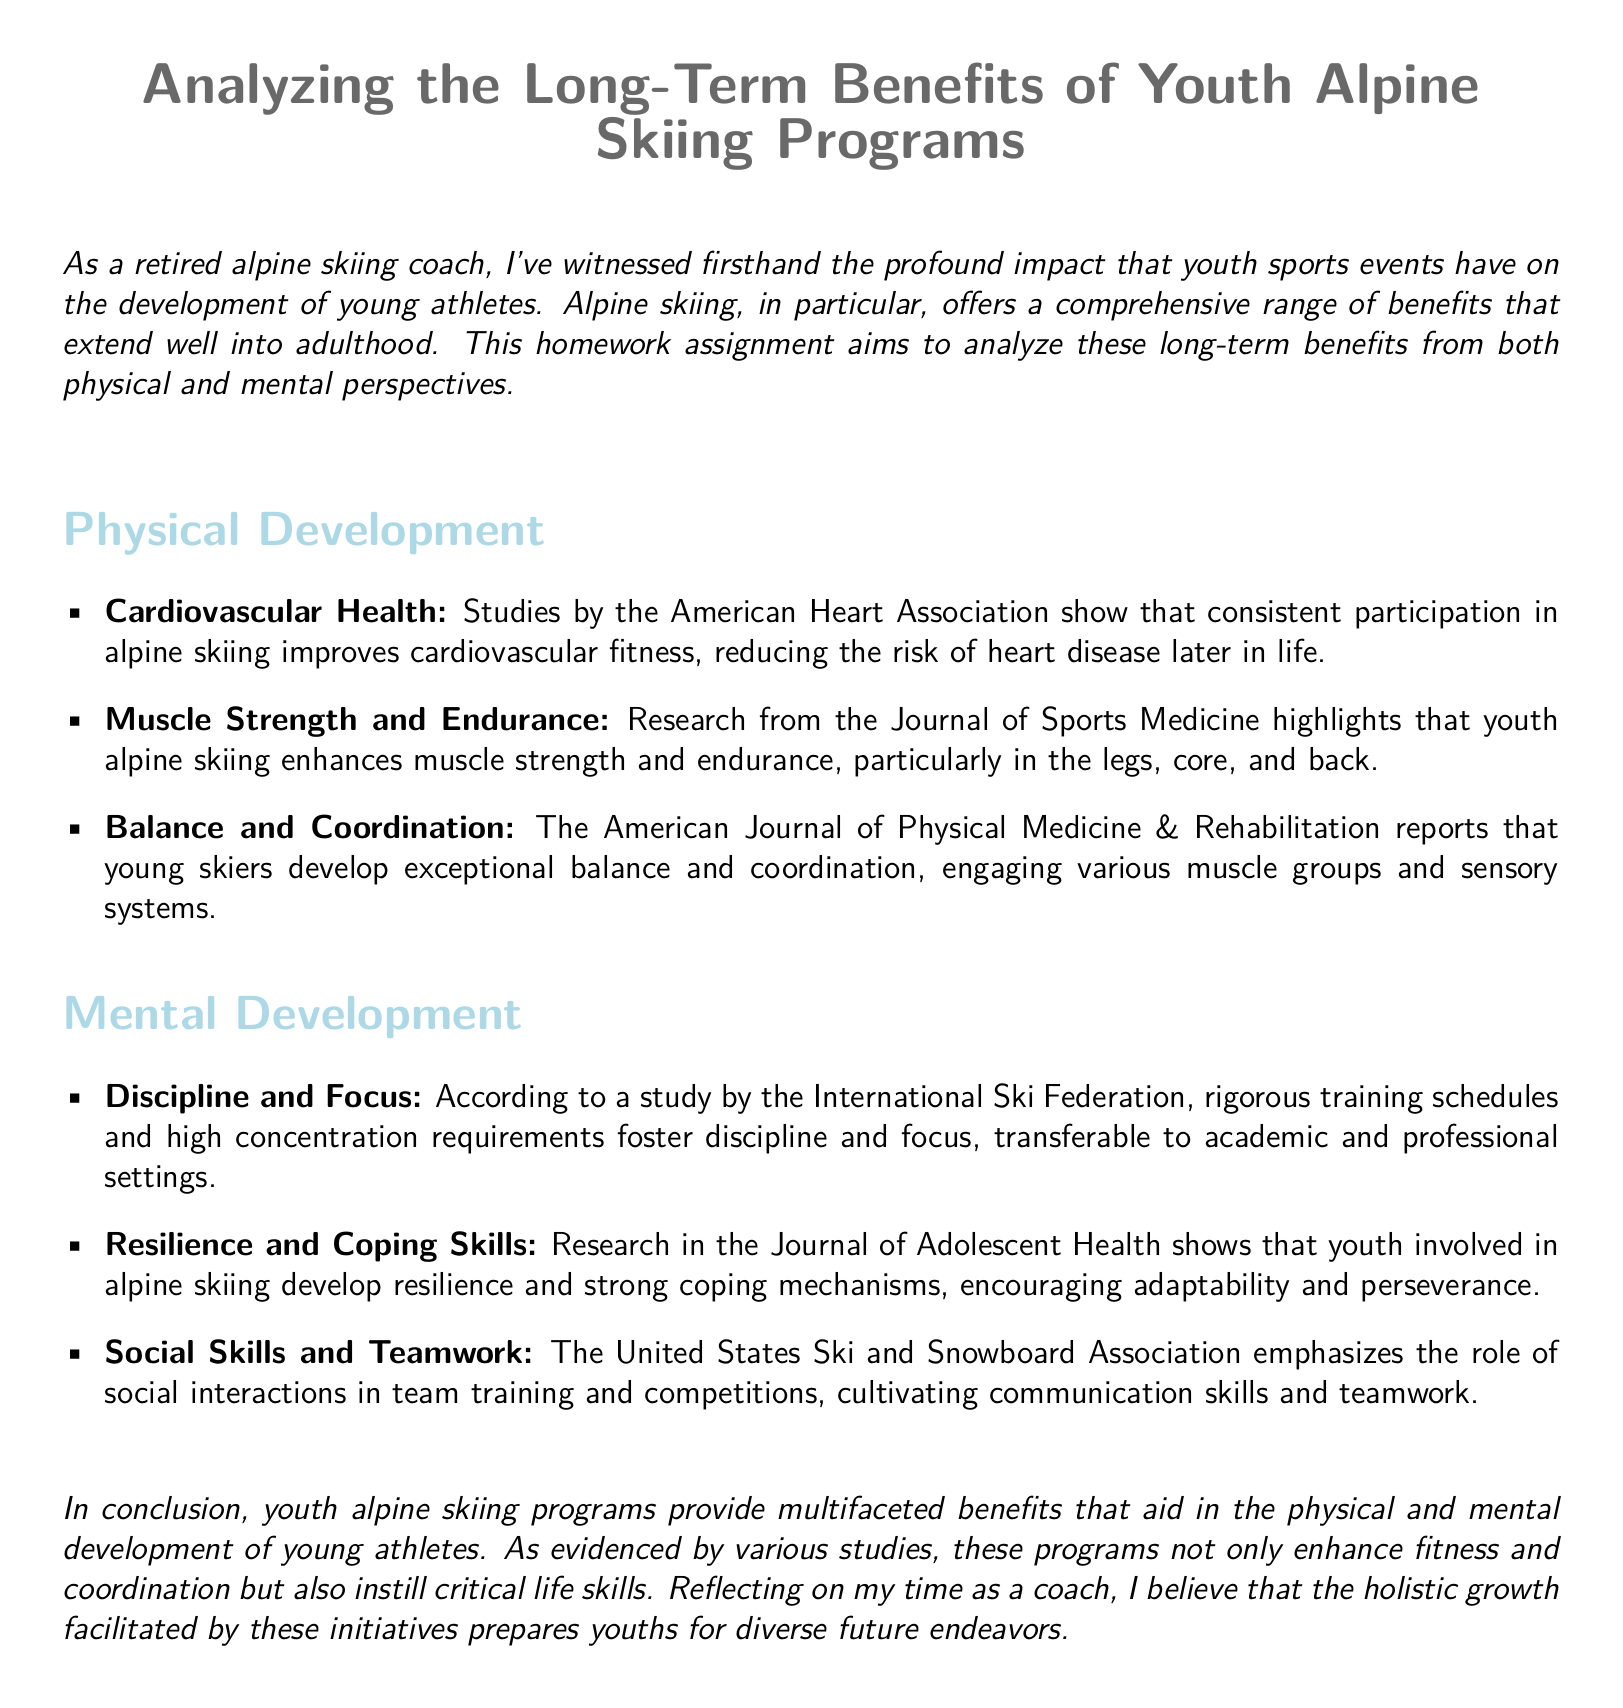What is the primary focus of the homework assignment? The assignment focuses on the long-term benefits of youth alpine skiing programs from both physical and mental perspectives.
Answer: Long-term benefits of youth alpine skiing programs What benefits are highlighted under physical development? The document lists cardiovascular health, muscle strength and endurance, balance, and coordination as physical development benefits.
Answer: Cardiovascular health, muscle strength and endurance, balance, coordination According to the document, which organization conducted research on resilience and coping skills? The research on resilience and coping skills was mentioned in the Journal of Adolescent Health.
Answer: Journal of Adolescent Health What does the American Journal of Physical Medicine & Rehabilitation report? It reports that young skiers develop exceptional balance and coordination.
Answer: Young skiers develop exceptional balance and coordination Which essential life skill is fostered by rigorous training schedules in alpine skiing? The rigorous training schedules foster discipline and focus.
Answer: Discipline and focus How does youth alpine skiing affect cardiovascular health? It improves cardiovascular fitness, reducing the risk of heart disease later in life.
Answer: Improves cardiovascular fitness What social benefits are associated with youth alpine skiing programs? The document emphasizes the cultivation of communication skills and teamwork through social interactions.
Answer: Communication skills and teamwork Which aspect of mental development is enhanced by participation in youth alpine skiing? The aspects include discipline, resilience, and social skills.
Answer: Discipline, resilience, social skills 